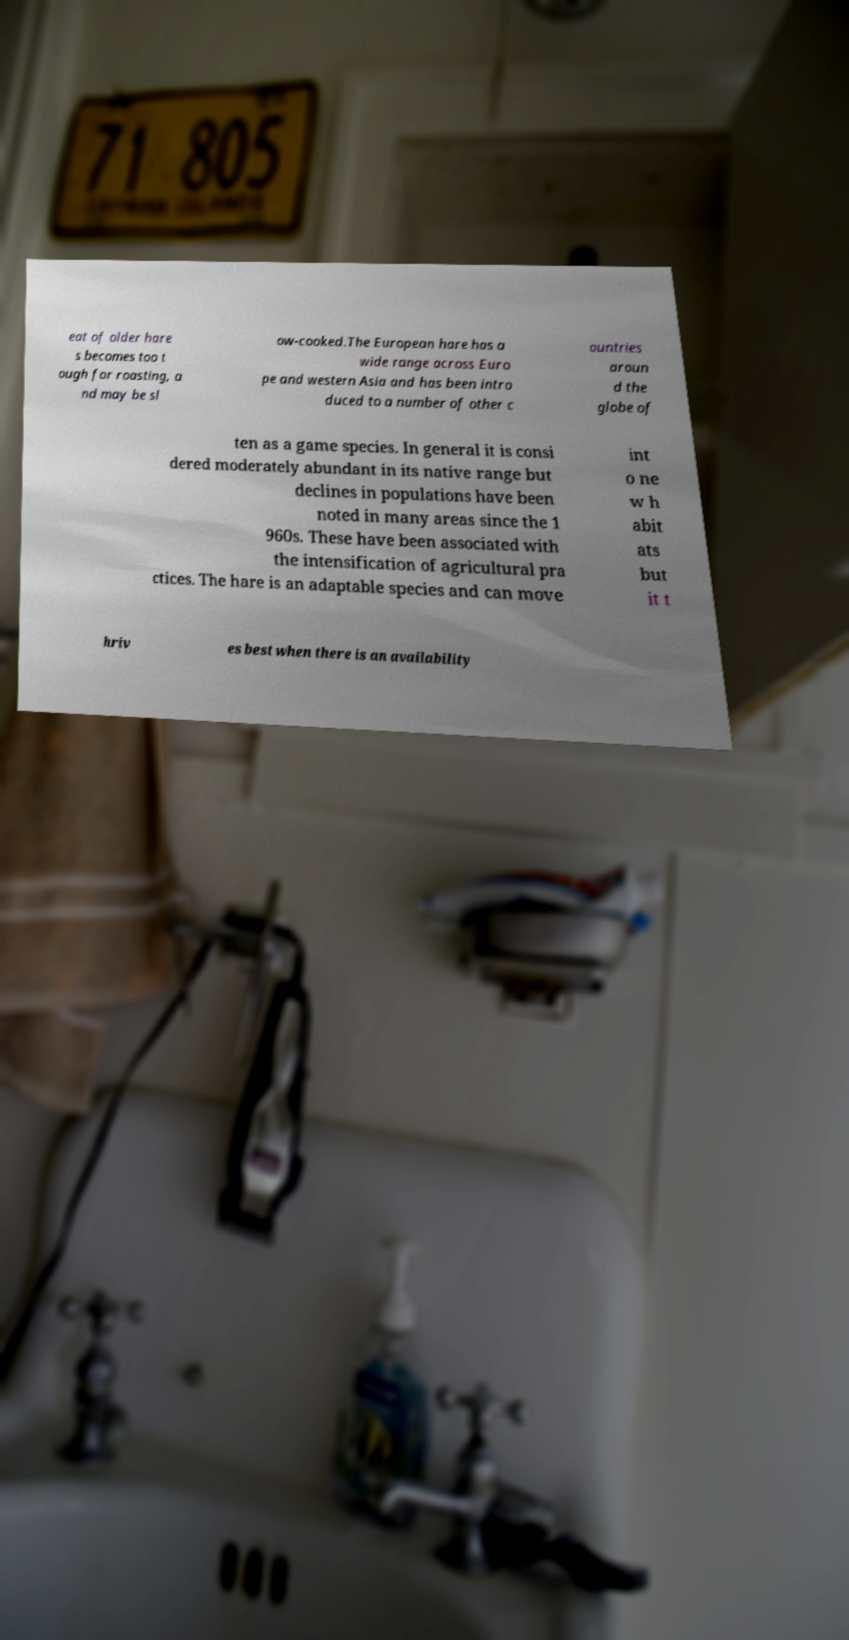Could you assist in decoding the text presented in this image and type it out clearly? eat of older hare s becomes too t ough for roasting, a nd may be sl ow-cooked.The European hare has a wide range across Euro pe and western Asia and has been intro duced to a number of other c ountries aroun d the globe of ten as a game species. In general it is consi dered moderately abundant in its native range but declines in populations have been noted in many areas since the 1 960s. These have been associated with the intensification of agricultural pra ctices. The hare is an adaptable species and can move int o ne w h abit ats but it t hriv es best when there is an availability 